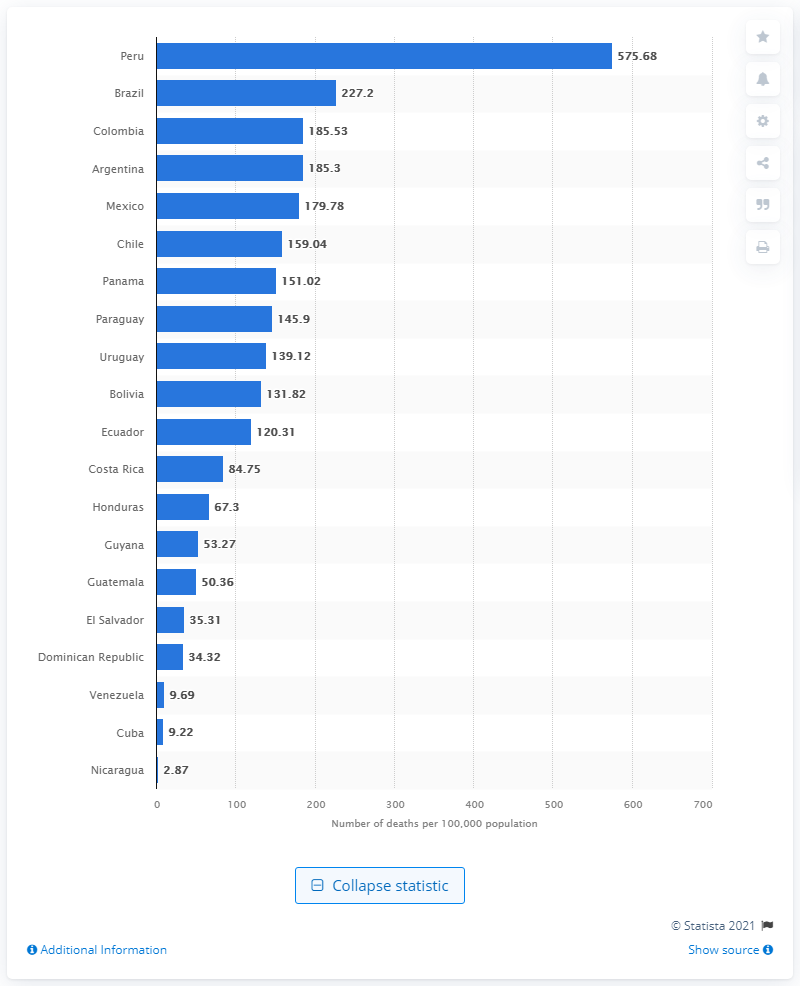Mention a couple of crucial points in this snapshot. Brazil has the highest mortality rate due to COVID-19 among all countries. 